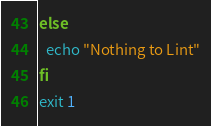Convert code to text. <code><loc_0><loc_0><loc_500><loc_500><_Bash_>else
  echo "Nothing to Lint"
fi
exit 1
</code> 